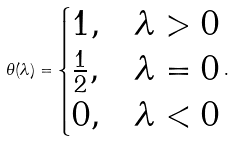Convert formula to latex. <formula><loc_0><loc_0><loc_500><loc_500>\theta ( \lambda ) = \begin{cases} 1 , & \lambda > 0 \\ \frac { 1 } { 2 } , & \lambda = 0 \\ 0 , & \lambda < 0 \end{cases} .</formula> 